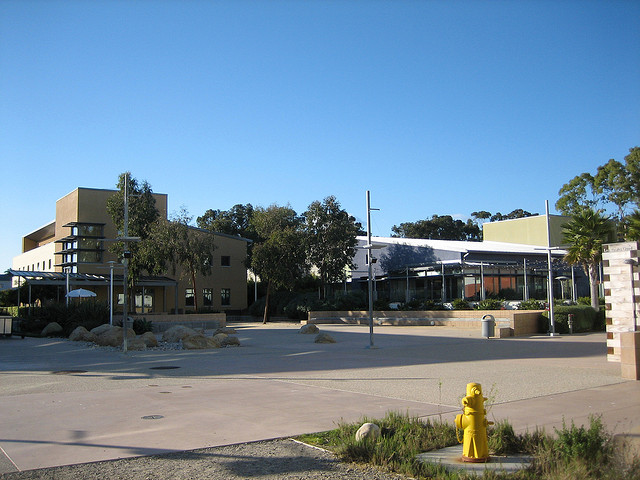What time of day does it appear to be in this image? Considering the long shadows and the angle of the sunlight on the buildings and trees, it seems to be either early morning or late afternoon. 